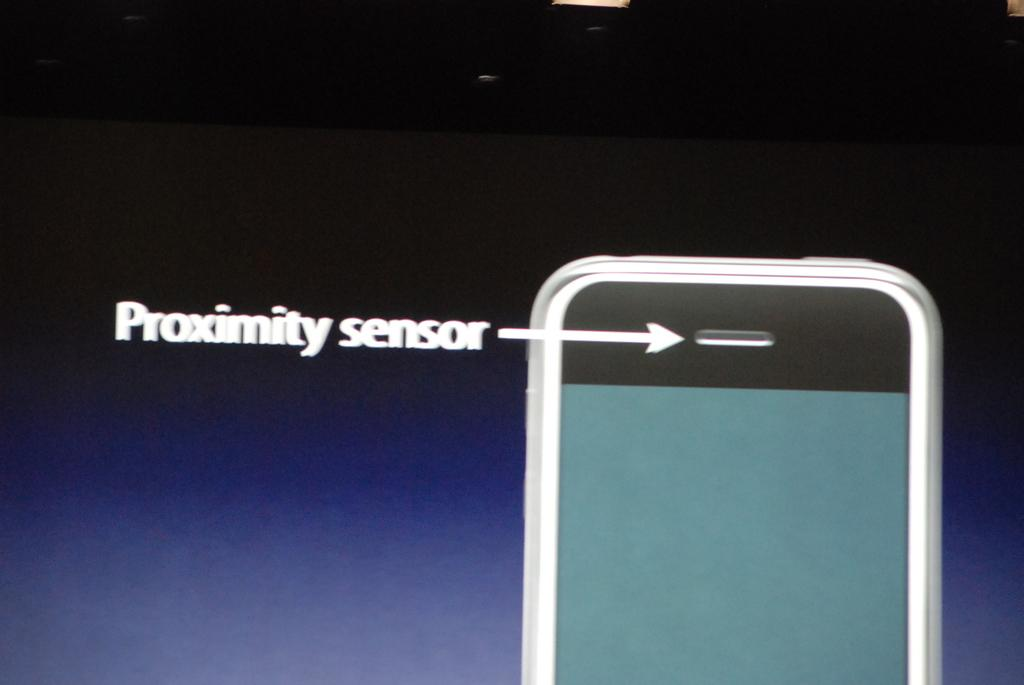<image>
Create a compact narrative representing the image presented. An image displaying the Proximity sensor on a cell phone. 